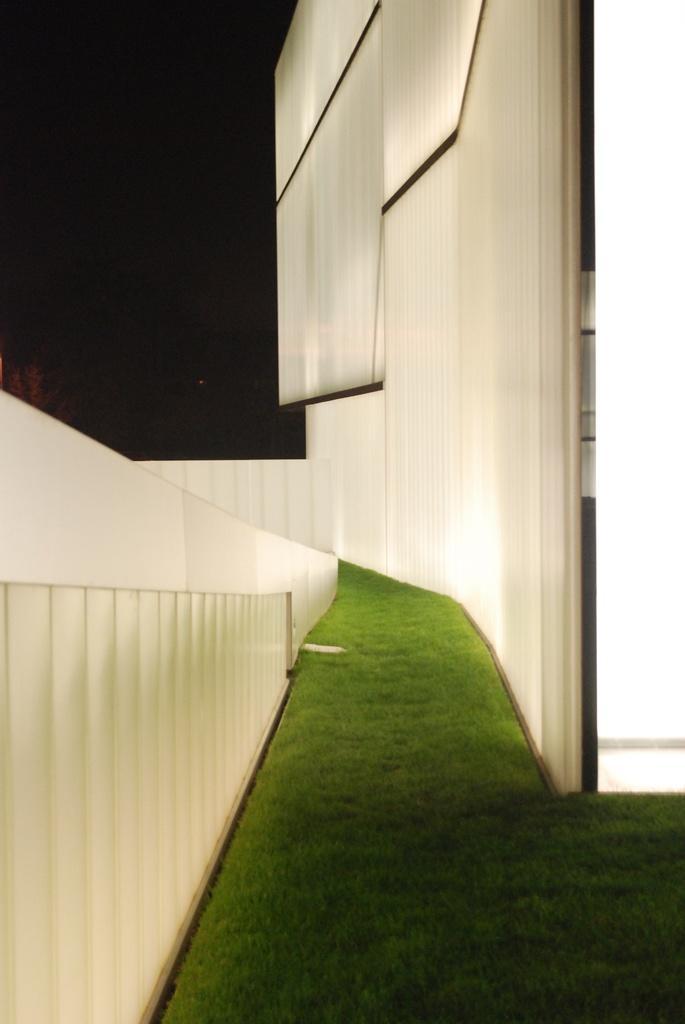Describe this image in one or two sentences. In this image I see the white walls and I see the green grass and It is dark in the background. 